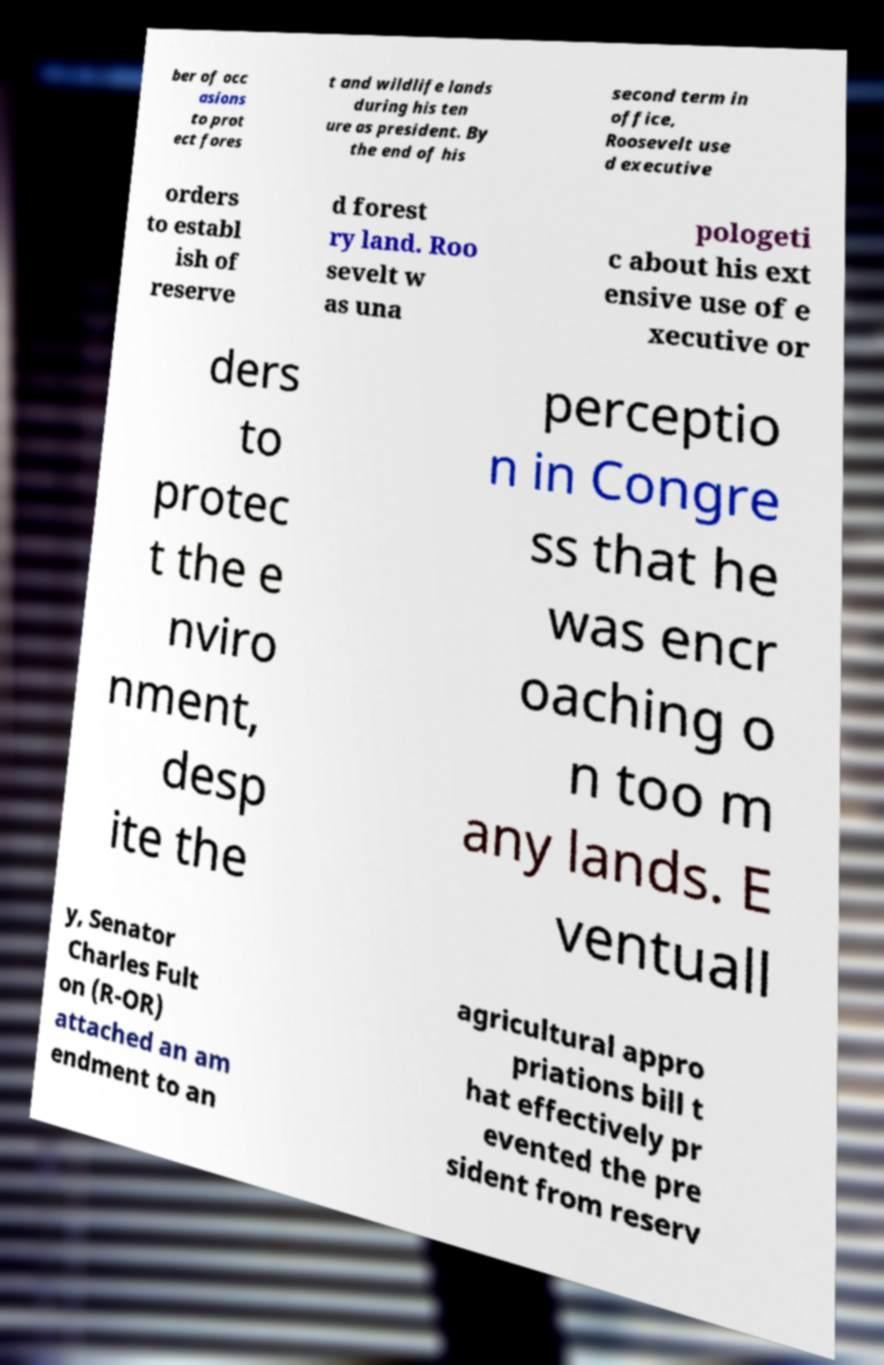What messages or text are displayed in this image? I need them in a readable, typed format. ber of occ asions to prot ect fores t and wildlife lands during his ten ure as president. By the end of his second term in office, Roosevelt use d executive orders to establ ish of reserve d forest ry land. Roo sevelt w as una pologeti c about his ext ensive use of e xecutive or ders to protec t the e nviro nment, desp ite the perceptio n in Congre ss that he was encr oaching o n too m any lands. E ventuall y, Senator Charles Fult on (R-OR) attached an am endment to an agricultural appro priations bill t hat effectively pr evented the pre sident from reserv 